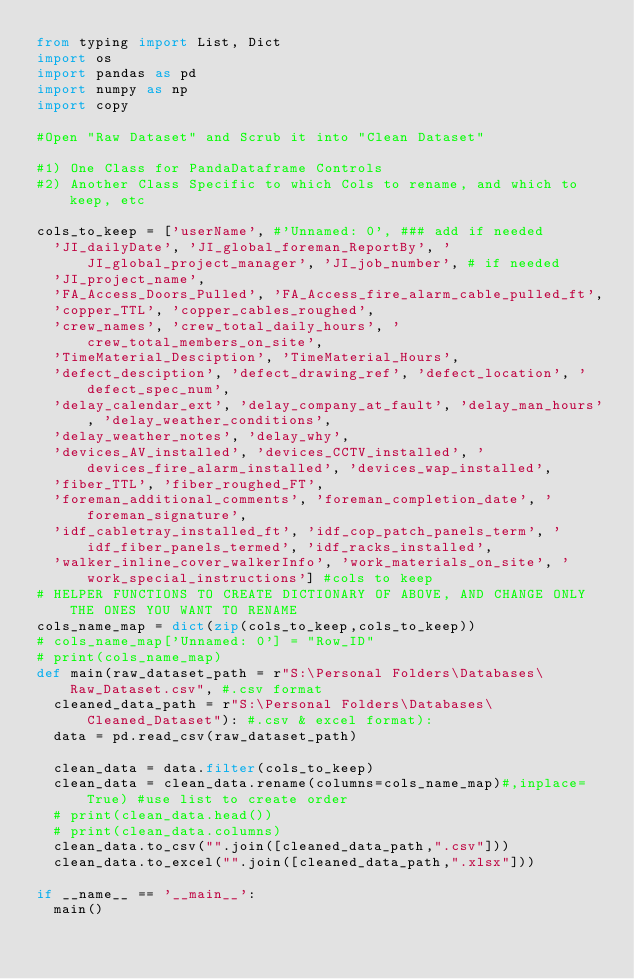Convert code to text. <code><loc_0><loc_0><loc_500><loc_500><_Python_>from typing import List, Dict
import os
import pandas as pd
import numpy as np
import copy

#Open "Raw Dataset" and Scrub it into "Clean Dataset"

#1) One Class for PandaDataframe Controls
#2) Another Class Specific to which Cols to rename, and which to keep, etc

cols_to_keep = ['userName', #'Unnamed: 0', ### add if needed 
	'JI_dailyDate', 'JI_global_foreman_ReportBy', 'JI_global_project_manager', 'JI_job_number', # if needed
	'JI_project_name', 
	'FA_Access_Doors_Pulled', 'FA_Access_fire_alarm_cable_pulled_ft',
	'copper_TTL', 'copper_cables_roughed',
	'crew_names', 'crew_total_daily_hours', 'crew_total_members_on_site', 
	'TimeMaterial_Desciption', 'TimeMaterial_Hours', 
	'defect_desciption', 'defect_drawing_ref', 'defect_location', 'defect_spec_num', 
	'delay_calendar_ext', 'delay_company_at_fault', 'delay_man_hours', 'delay_weather_conditions', 
	'delay_weather_notes', 'delay_why', 
	'devices_AV_installed', 'devices_CCTV_installed', 'devices_fire_alarm_installed', 'devices_wap_installed',  
	'fiber_TTL', 'fiber_roughed_FT',
	'foreman_additional_comments', 'foreman_completion_date', 'foreman_signature',
	'idf_cabletray_installed_ft', 'idf_cop_patch_panels_term', 'idf_fiber_panels_termed', 'idf_racks_installed',  
	'walker_inline_cover_walkerInfo', 'work_materials_on_site', 'work_special_instructions'] #cols to keep
# HELPER FUNCTIONS TO CREATE DICTIONARY OF ABOVE, AND CHANGE ONLY THE ONES YOU WANT TO RENAME
cols_name_map = dict(zip(cols_to_keep,cols_to_keep))
# cols_name_map['Unnamed: 0'] = "Row_ID"
# print(cols_name_map)
def main(raw_dataset_path = r"S:\Personal Folders\Databases\Raw_Dataset.csv", #.csv format
	cleaned_data_path = r"S:\Personal Folders\Databases\Cleaned_Dataset"): #.csv & excel format):
	data = pd.read_csv(raw_dataset_path)

	clean_data = data.filter(cols_to_keep)
	clean_data = clean_data.rename(columns=cols_name_map)#,inplace=True) #use list to create order
	# print(clean_data.head())
	# print(clean_data.columns)
	clean_data.to_csv("".join([cleaned_data_path,".csv"]))
	clean_data.to_excel("".join([cleaned_data_path,".xlsx"]))

if __name__ == '__main__':
	main()</code> 